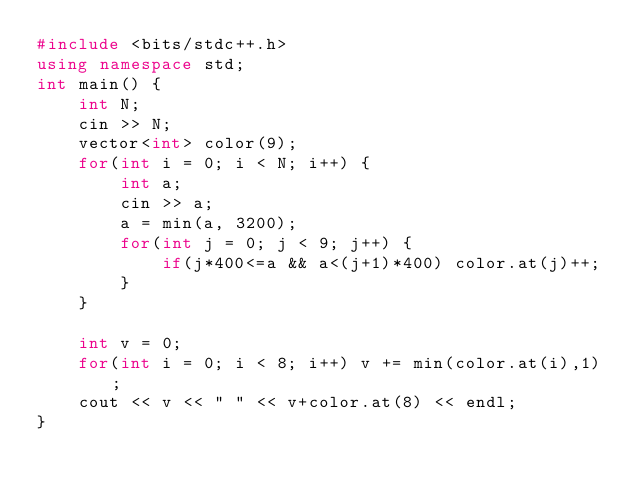<code> <loc_0><loc_0><loc_500><loc_500><_C++_>#include <bits/stdc++.h>
using namespace std;
int main() {
    int N;
    cin >> N;
    vector<int> color(9);
    for(int i = 0; i < N; i++) {
        int a;
        cin >> a;
        a = min(a, 3200);
        for(int j = 0; j < 9; j++) {
            if(j*400<=a && a<(j+1)*400) color.at(j)++;
        }
    }
    
    int v = 0;
    for(int i = 0; i < 8; i++) v += min(color.at(i),1);
    cout << v << " " << v+color.at(8) << endl;
}
</code> 